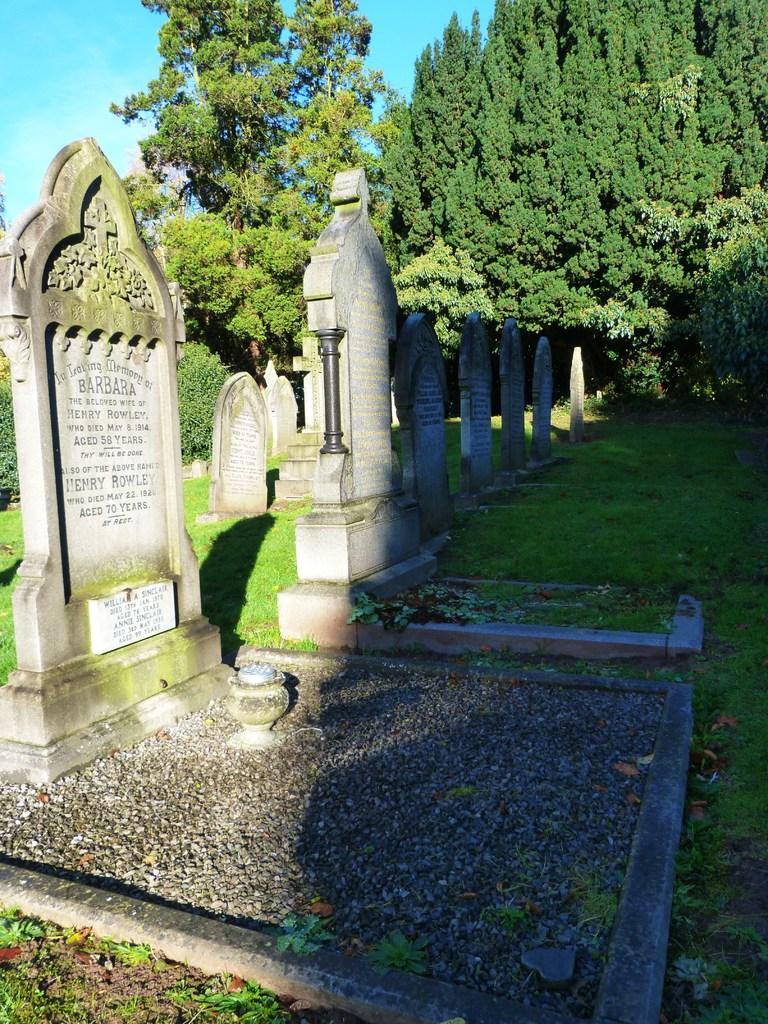Could you give a brief overview of what you see in this image? In this picture we can see memorials, at the bottom there is grass, we can see trees in the background, there is the sky at the left top of the picture. 